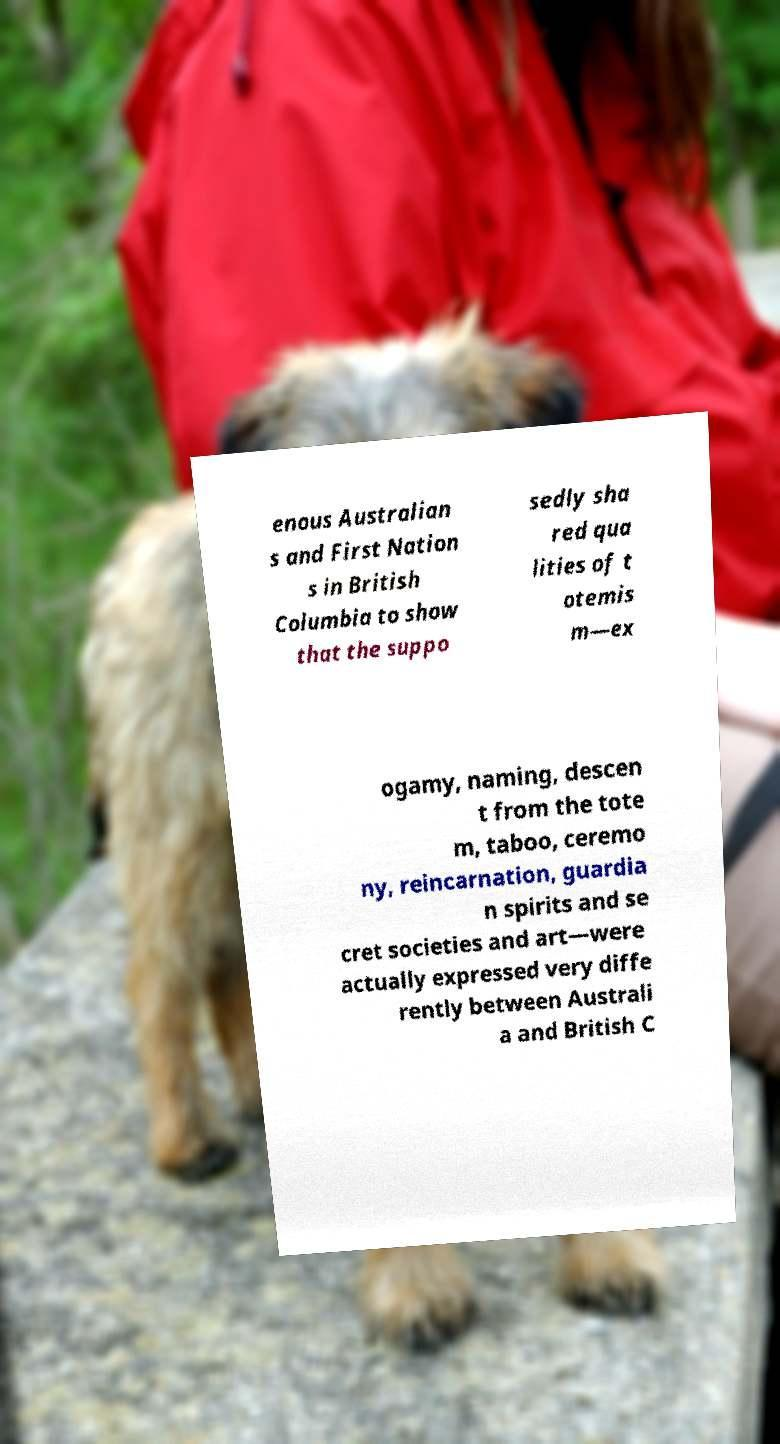What messages or text are displayed in this image? I need them in a readable, typed format. enous Australian s and First Nation s in British Columbia to show that the suppo sedly sha red qua lities of t otemis m—ex ogamy, naming, descen t from the tote m, taboo, ceremo ny, reincarnation, guardia n spirits and se cret societies and art—were actually expressed very diffe rently between Australi a and British C 